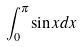<formula> <loc_0><loc_0><loc_500><loc_500>\int _ { 0 } ^ { \pi } \sin x d x</formula> 